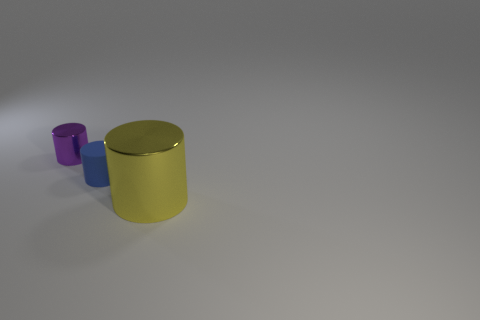Subtract all large yellow metal cylinders. How many cylinders are left? 2 Add 2 blue cylinders. How many objects exist? 5 Subtract all blue cylinders. How many cylinders are left? 2 Subtract 1 cylinders. How many cylinders are left? 2 Subtract 0 red spheres. How many objects are left? 3 Subtract all gray cylinders. Subtract all red blocks. How many cylinders are left? 3 Subtract all purple cylinders. Subtract all yellow cylinders. How many objects are left? 1 Add 2 small purple objects. How many small purple objects are left? 3 Add 2 metallic cylinders. How many metallic cylinders exist? 4 